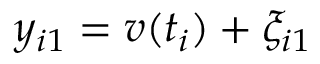Convert formula to latex. <formula><loc_0><loc_0><loc_500><loc_500>y _ { i 1 } = v ( t _ { i } ) + \xi _ { i 1 }</formula> 